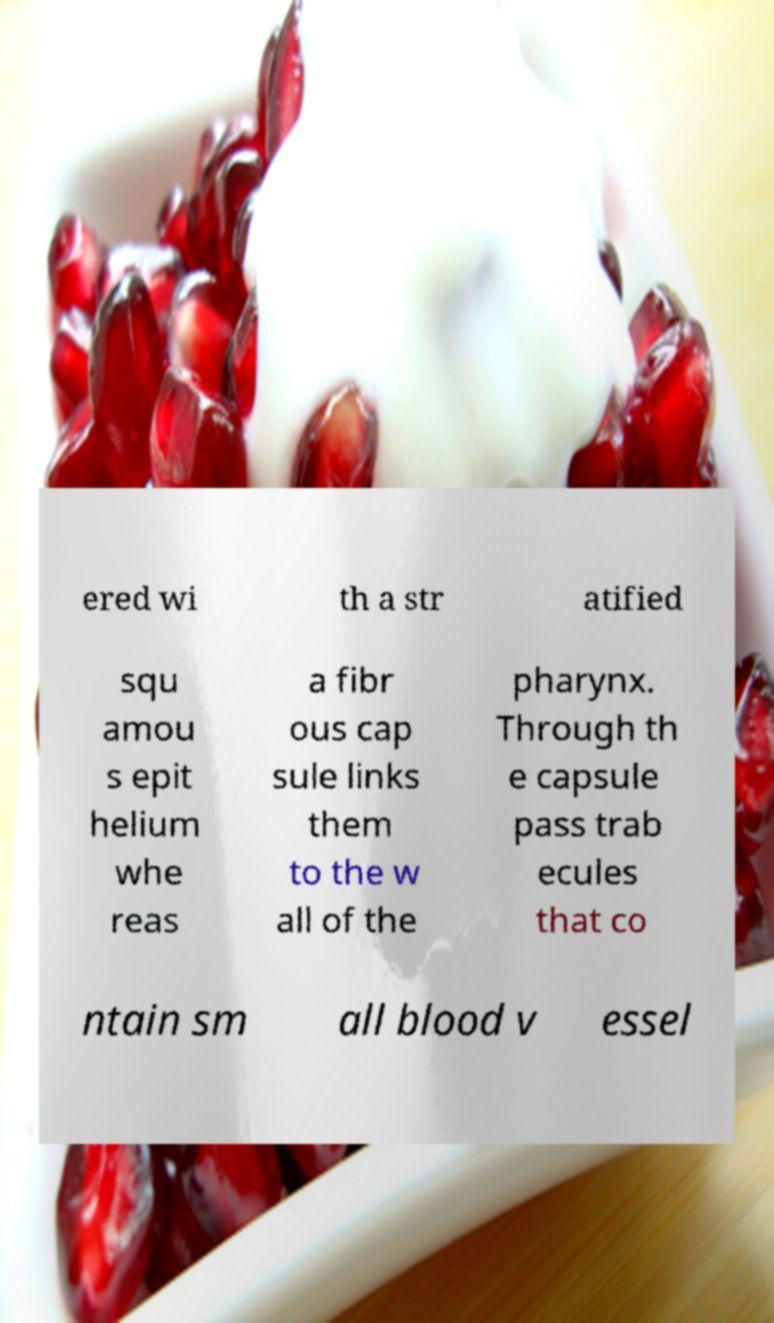Can you read and provide the text displayed in the image?This photo seems to have some interesting text. Can you extract and type it out for me? ered wi th a str atified squ amou s epit helium whe reas a fibr ous cap sule links them to the w all of the pharynx. Through th e capsule pass trab ecules that co ntain sm all blood v essel 